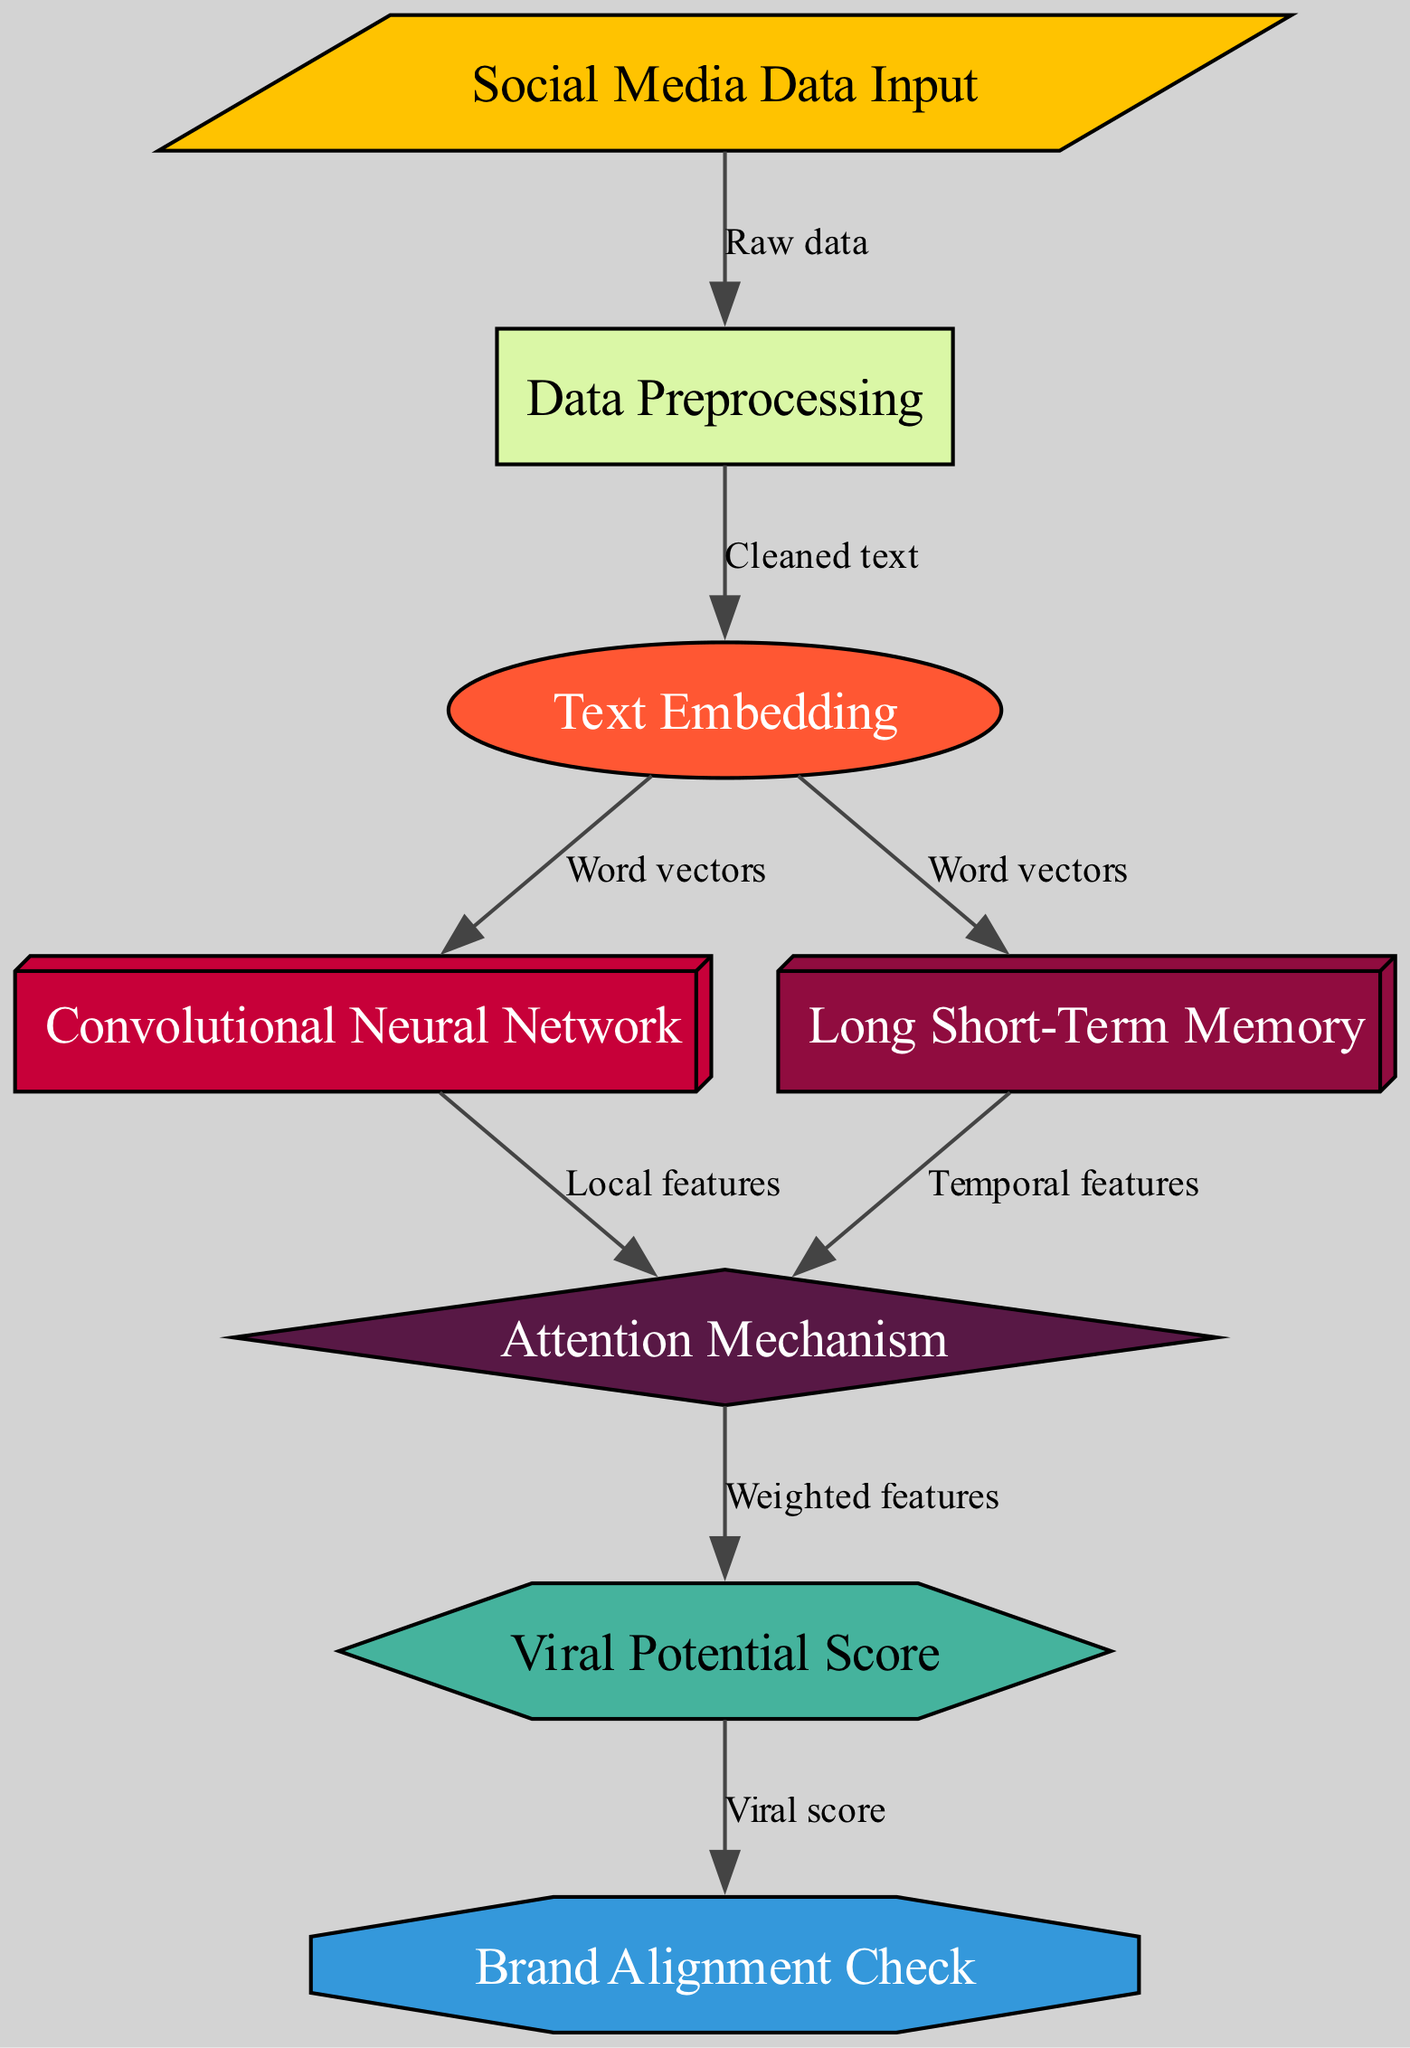What is the first node in the diagram? The diagram starts with the "Social Media Data Input" node, which is the initial point of the data flow in the neural network.
Answer: Social Media Data Input How many nodes are there in total? By counting all the distinct nodes listed, I identify eight separate nodes within the diagram.
Answer: 8 What type of neural network is used after text embedding? The diagram indicates that a Convolutional Neural Network follows the text embedding step, as shown in the flow from "Text Embedding" to "Convolutional Neural Network."
Answer: Convolutional Neural Network Which mechanism combines features from both local and temporal contexts? The Attention Mechanism node receives input from both the Convolutional Neural Network and the Long Short-Term Memory, thus combining their respective features.
Answer: Attention Mechanism What is the final output of the model? The output node labeled "Viral Potential Score" is the ultimate result of the neural network's analysis, as indicated at the end of the flow, following the attention mechanism.
Answer: Viral Potential Score Which node checks for brand alignment? The diagram clearly shows that the node labeled "Brand Alignment Check" receives the viral score output, indicating it is responsible for ensuring that the content aligns with brand messaging.
Answer: Brand Alignment Check What does the edge from "Embedding" lead to? The edge from the "Text Embedding" node indicates that word vectors are passed to two separate nodes: the Convolutional Neural Network and Long Short-Term Memory.
Answer: Convolutional Neural Network, Long Short-Term Memory What feature is extracted by the Convolutional Neural Network? The diagram specifies that the Convolutional Neural Network extracts "Local features" based on the input it receives from the word vectors.
Answer: Local features 